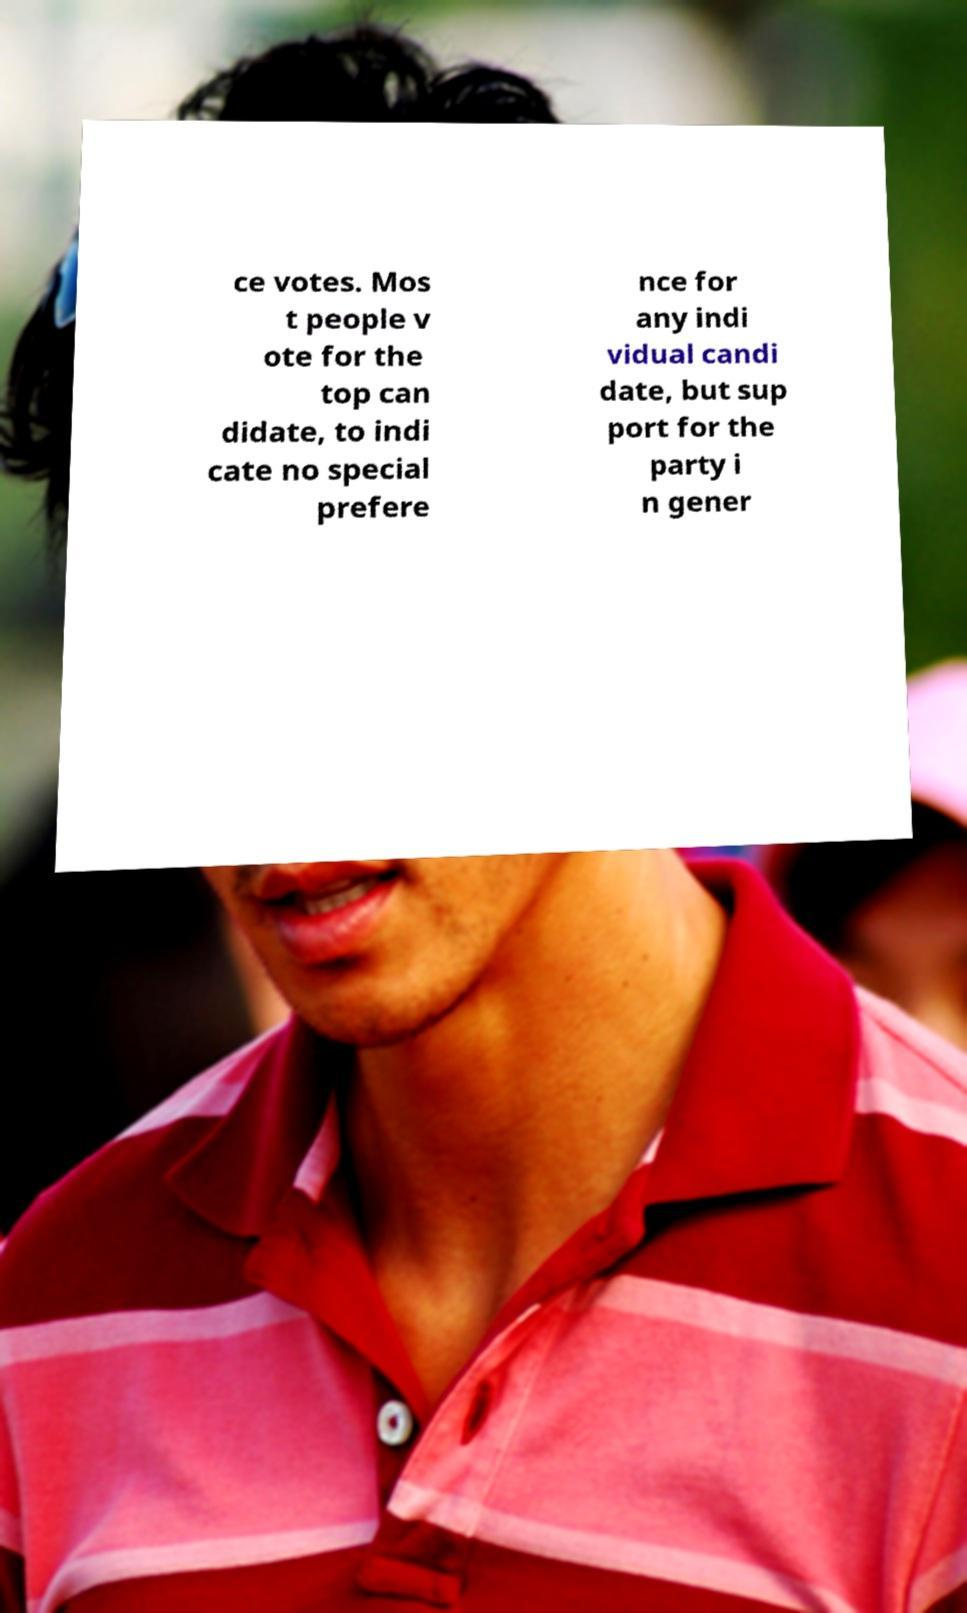What messages or text are displayed in this image? I need them in a readable, typed format. ce votes. Mos t people v ote for the top can didate, to indi cate no special prefere nce for any indi vidual candi date, but sup port for the party i n gener 